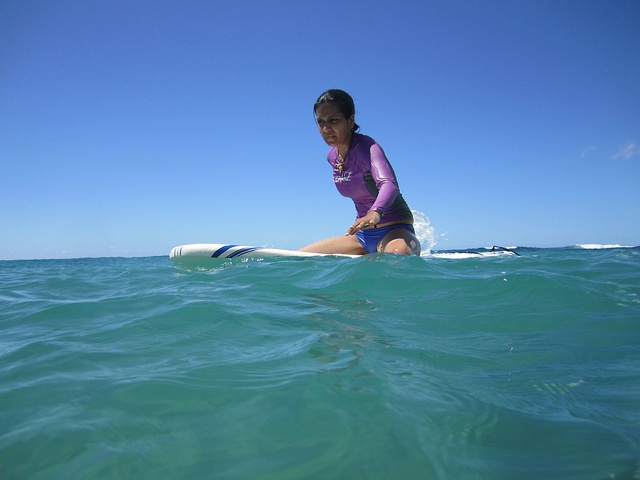Describe the objects in this image and their specific colors. I can see people in blue, black, navy, purple, and gray tones and surfboard in blue, teal, white, and darkgray tones in this image. 